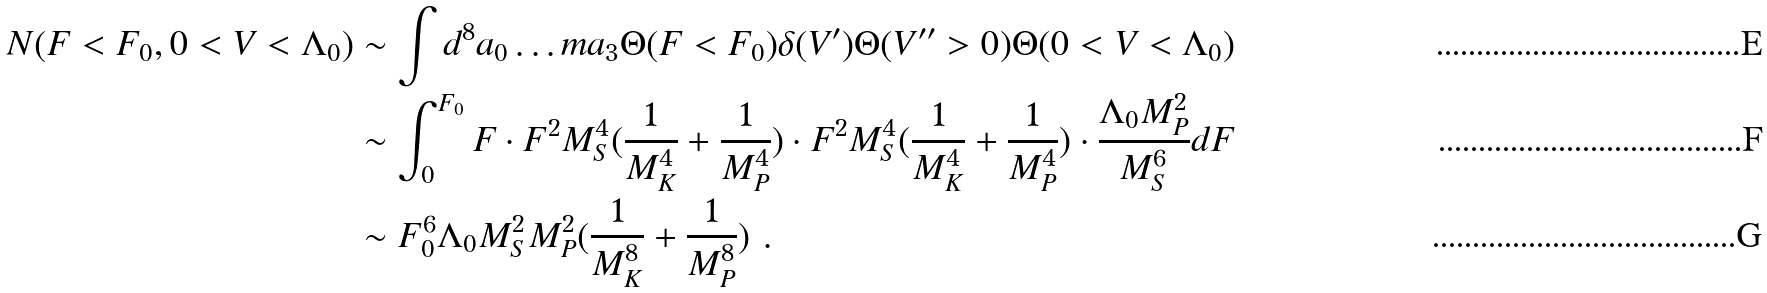Convert formula to latex. <formula><loc_0><loc_0><loc_500><loc_500>N ( F < F _ { 0 } , 0 < V < \Lambda _ { 0 } ) & \sim \int d ^ { 8 } a _ { 0 } \dots m a _ { 3 } \Theta ( F < F _ { 0 } ) \delta ( V ^ { \prime } ) \Theta ( V ^ { \prime \prime } > 0 ) \Theta ( 0 < V < \Lambda _ { 0 } ) \\ & \sim \int _ { 0 } ^ { F _ { 0 } } F \cdot F ^ { 2 } M _ { S } ^ { 4 } ( \frac { 1 } { M _ { K } ^ { 4 } } + \frac { 1 } { M _ { P } ^ { 4 } } ) \cdot F ^ { 2 } M _ { S } ^ { 4 } ( \frac { 1 } { M _ { K } ^ { 4 } } + \frac { 1 } { M _ { P } ^ { 4 } } ) \cdot \frac { \Lambda _ { 0 } M _ { P } ^ { 2 } } { M _ { S } ^ { 6 } } d F \\ & \sim F _ { 0 } ^ { 6 } \Lambda _ { 0 } M _ { S } ^ { 2 } M _ { P } ^ { 2 } ( \frac { 1 } { M _ { K } ^ { 8 } } + \frac { 1 } { M _ { P } ^ { 8 } } ) \ .</formula> 